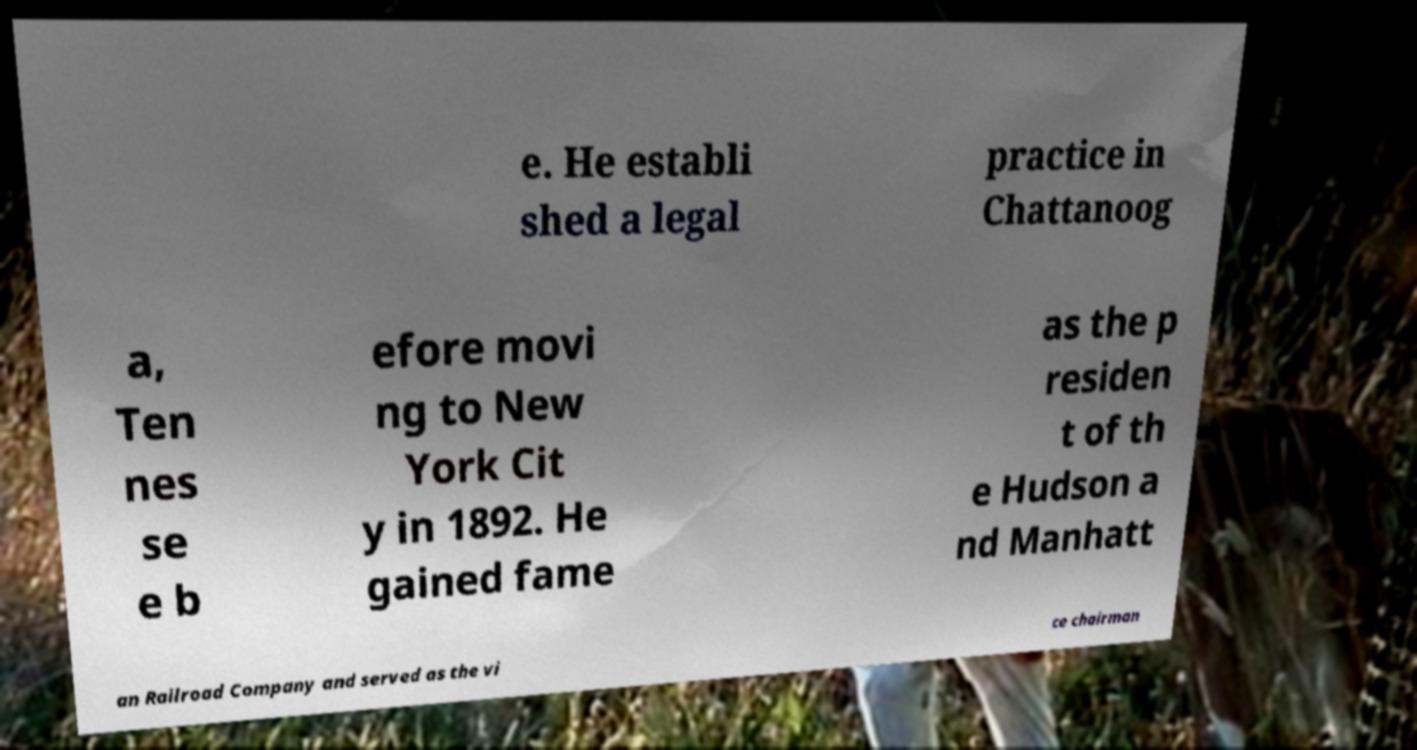Can you accurately transcribe the text from the provided image for me? e. He establi shed a legal practice in Chattanoog a, Ten nes se e b efore movi ng to New York Cit y in 1892. He gained fame as the p residen t of th e Hudson a nd Manhatt an Railroad Company and served as the vi ce chairman 